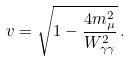Convert formula to latex. <formula><loc_0><loc_0><loc_500><loc_500>v = \sqrt { 1 - \frac { 4 m _ { \mu } ^ { 2 } } { W _ { \gamma \gamma } ^ { 2 } } } \, .</formula> 